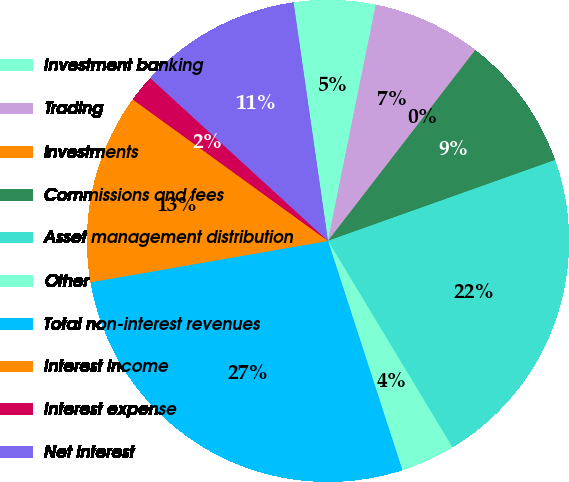Convert chart. <chart><loc_0><loc_0><loc_500><loc_500><pie_chart><fcel>Investment banking<fcel>Trading<fcel>Investments<fcel>Commissions and fees<fcel>Asset management distribution<fcel>Other<fcel>Total non-interest revenues<fcel>Interest income<fcel>Interest expense<fcel>Net interest<nl><fcel>5.46%<fcel>7.28%<fcel>0.01%<fcel>9.09%<fcel>21.81%<fcel>3.64%<fcel>27.25%<fcel>12.72%<fcel>1.83%<fcel>10.91%<nl></chart> 